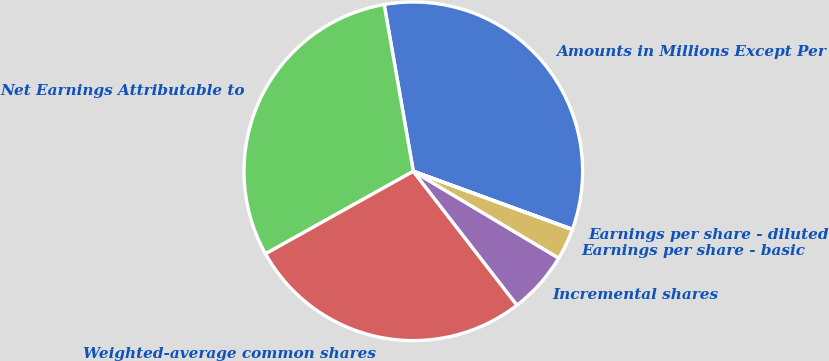Convert chart to OTSL. <chart><loc_0><loc_0><loc_500><loc_500><pie_chart><fcel>Amounts in Millions Except Per<fcel>Net Earnings Attributable to<fcel>Weighted-average common shares<fcel>Incremental shares<fcel>Earnings per share - basic<fcel>Earnings per share - diluted<nl><fcel>33.32%<fcel>30.35%<fcel>27.38%<fcel>5.95%<fcel>2.98%<fcel>0.02%<nl></chart> 